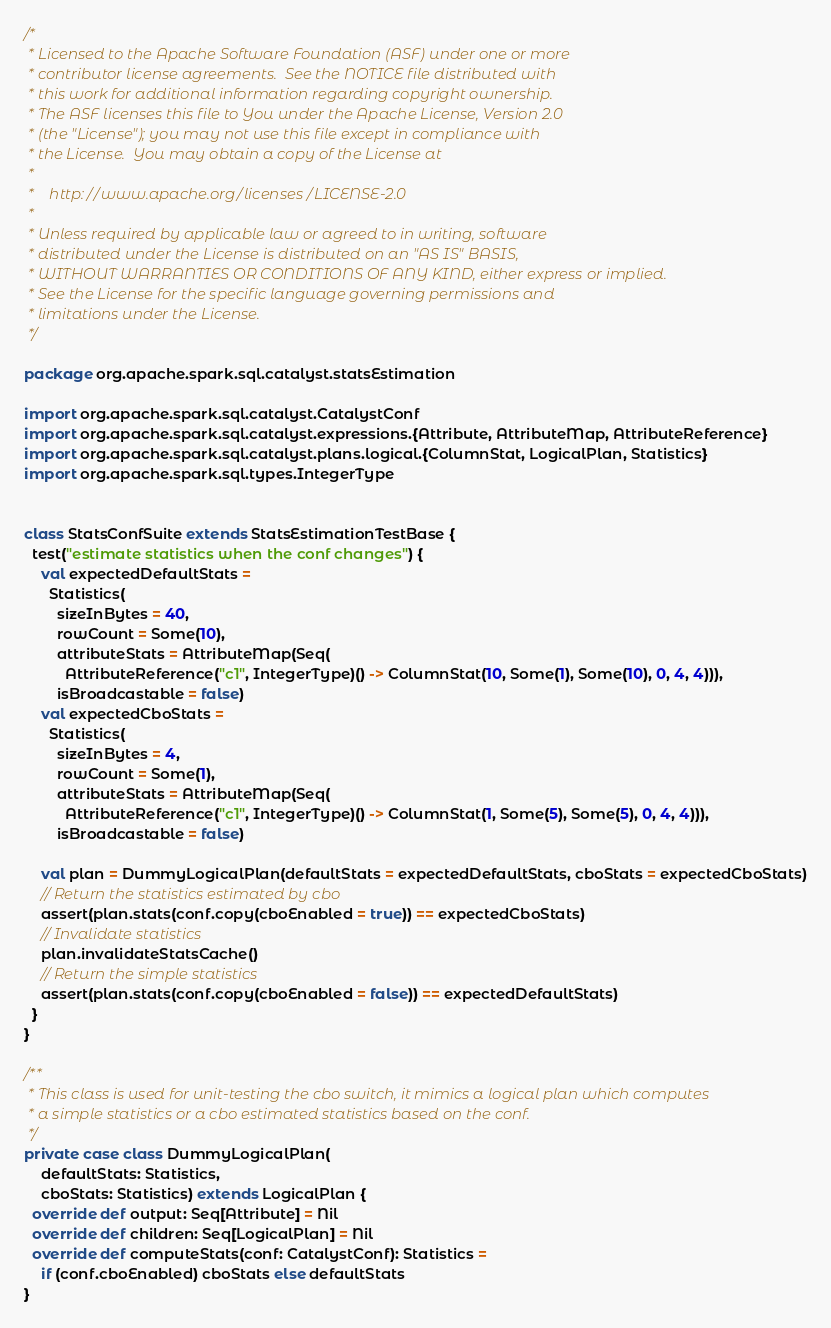<code> <loc_0><loc_0><loc_500><loc_500><_Scala_>/*
 * Licensed to the Apache Software Foundation (ASF) under one or more
 * contributor license agreements.  See the NOTICE file distributed with
 * this work for additional information regarding copyright ownership.
 * The ASF licenses this file to You under the Apache License, Version 2.0
 * (the "License"); you may not use this file except in compliance with
 * the License.  You may obtain a copy of the License at
 *
 *    http://www.apache.org/licenses/LICENSE-2.0
 *
 * Unless required by applicable law or agreed to in writing, software
 * distributed under the License is distributed on an "AS IS" BASIS,
 * WITHOUT WARRANTIES OR CONDITIONS OF ANY KIND, either express or implied.
 * See the License for the specific language governing permissions and
 * limitations under the License.
 */

package org.apache.spark.sql.catalyst.statsEstimation

import org.apache.spark.sql.catalyst.CatalystConf
import org.apache.spark.sql.catalyst.expressions.{Attribute, AttributeMap, AttributeReference}
import org.apache.spark.sql.catalyst.plans.logical.{ColumnStat, LogicalPlan, Statistics}
import org.apache.spark.sql.types.IntegerType


class StatsConfSuite extends StatsEstimationTestBase {
  test("estimate statistics when the conf changes") {
    val expectedDefaultStats =
      Statistics(
        sizeInBytes = 40,
        rowCount = Some(10),
        attributeStats = AttributeMap(Seq(
          AttributeReference("c1", IntegerType)() -> ColumnStat(10, Some(1), Some(10), 0, 4, 4))),
        isBroadcastable = false)
    val expectedCboStats =
      Statistics(
        sizeInBytes = 4,
        rowCount = Some(1),
        attributeStats = AttributeMap(Seq(
          AttributeReference("c1", IntegerType)() -> ColumnStat(1, Some(5), Some(5), 0, 4, 4))),
        isBroadcastable = false)

    val plan = DummyLogicalPlan(defaultStats = expectedDefaultStats, cboStats = expectedCboStats)
    // Return the statistics estimated by cbo
    assert(plan.stats(conf.copy(cboEnabled = true)) == expectedCboStats)
    // Invalidate statistics
    plan.invalidateStatsCache()
    // Return the simple statistics
    assert(plan.stats(conf.copy(cboEnabled = false)) == expectedDefaultStats)
  }
}

/**
 * This class is used for unit-testing the cbo switch, it mimics a logical plan which computes
 * a simple statistics or a cbo estimated statistics based on the conf.
 */
private case class DummyLogicalPlan(
    defaultStats: Statistics,
    cboStats: Statistics) extends LogicalPlan {
  override def output: Seq[Attribute] = Nil
  override def children: Seq[LogicalPlan] = Nil
  override def computeStats(conf: CatalystConf): Statistics =
    if (conf.cboEnabled) cboStats else defaultStats
}
</code> 